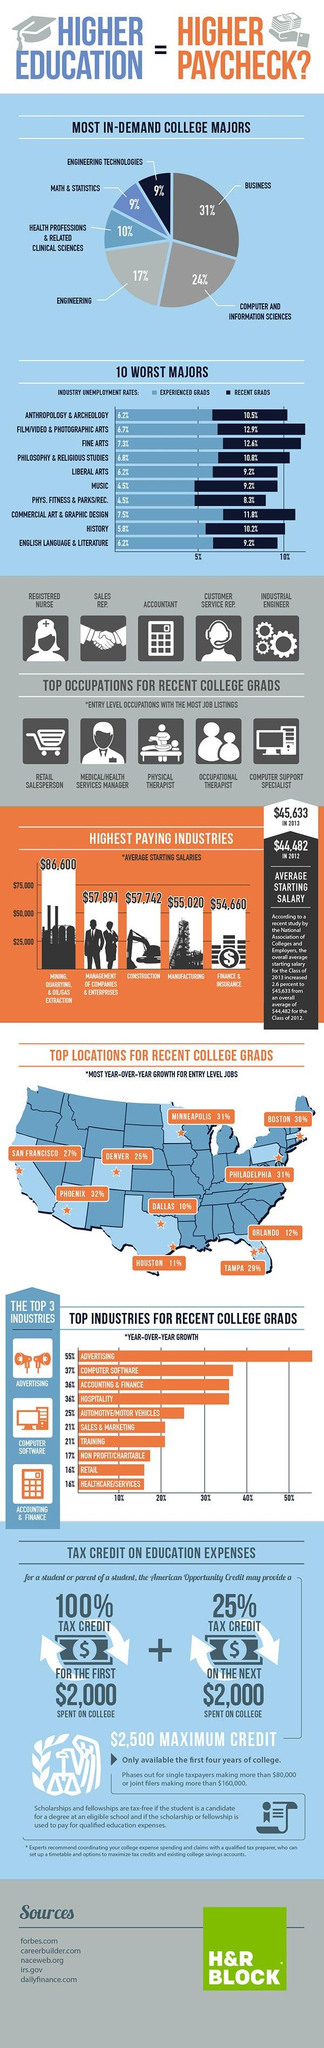Draw attention to some important aspects in this diagram. The unemployment rate for recent graduates in the commercial art and graphic design industry is 11.8%. In the fine arts industry, the unemployment rate for experienced graduates is 7.3%. On average, employees working in the manufacturing field in the United States earned a starting salary of $55,020 in 2013. In 2013, the average starting salary for employees working in the construction field in the United States was $57,742. Computer and Information Sciences is the second most in-demand college major in the United States. 